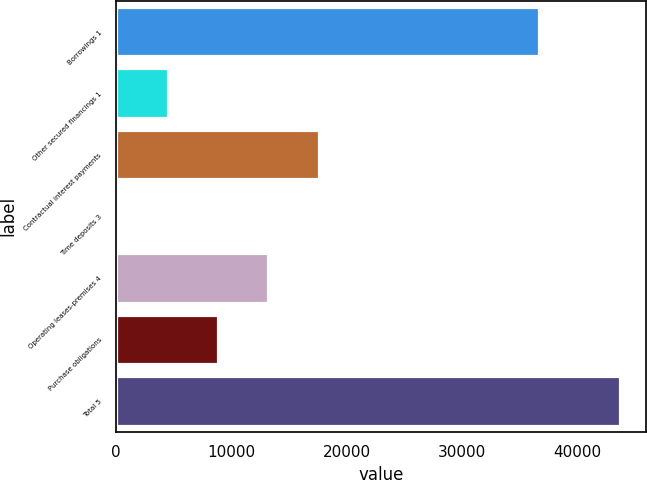Convert chart. <chart><loc_0><loc_0><loc_500><loc_500><bar_chart><fcel>Borrowings 1<fcel>Other secured financings 1<fcel>Contractual interest payments<fcel>Time deposits 3<fcel>Operating leases-premises 4<fcel>Purchase obligations<fcel>Total 5<nl><fcel>36649<fcel>4471.7<fcel>17562.8<fcel>108<fcel>13199.1<fcel>8835.4<fcel>43745<nl></chart> 